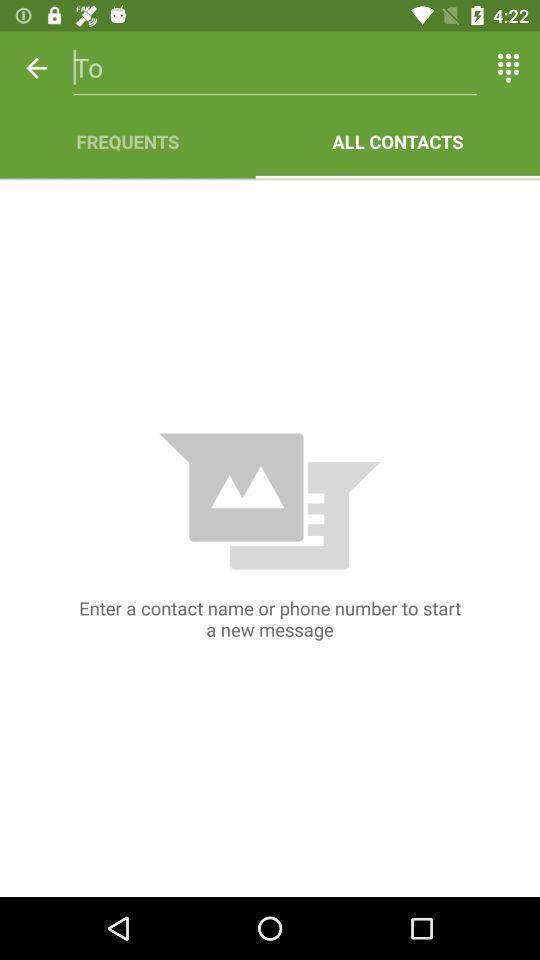Provide a textual representation of this image. Screen displaying to enter contact name in app. 